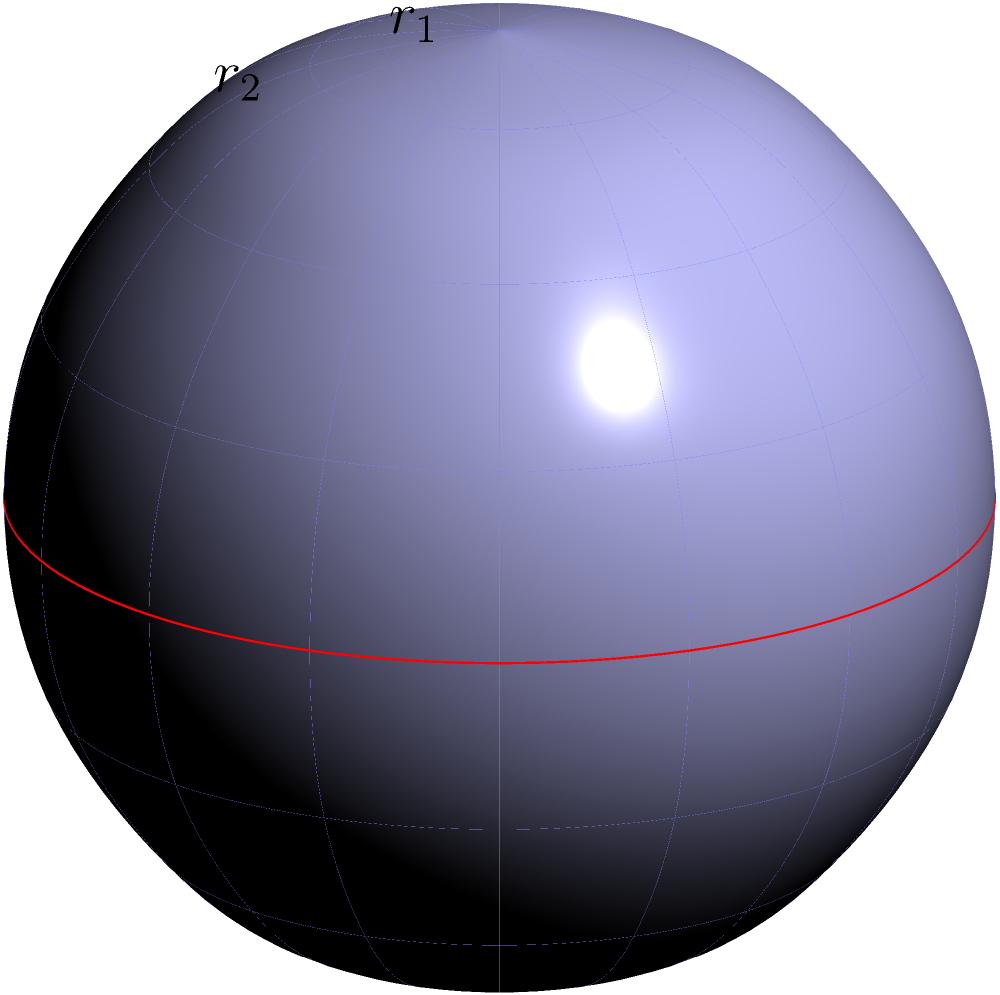On a sphere of radius $R$, two concentric circles are drawn with radii $r_1$ and $r_2$ (where $r_2 > r_1$) as measured along the surface of the sphere. If the area between these circles is $A$, express $A$ in terms of $R$, $r_1$, and $r_2$. To solve this problem, we'll follow these steps:

1) First, recall the formula for the area of a spherical cap: $A_{cap} = 2\pi R h$, where $R$ is the radius of the sphere and $h$ is the height of the cap.

2) The height $h$ can be expressed in terms of the radius $R$ and the circle radius $r$: $h = R - R \cos(\frac{r}{R})$

3) Therefore, the area of a spherical cap with radius $r$ is:
   $A_{cap} = 2\pi R^2 (1 - \cos(\frac{r}{R}))$

4) The area between our two concentric circles is the difference between the areas of two spherical caps:
   $A = A_{cap2} - A_{cap1}$

5) Substituting the formula from step 3:
   $A = 2\pi R^2 (1 - \cos(\frac{r_2}{R})) - 2\pi R^2 (1 - \cos(\frac{r_1}{R}))$

6) Simplifying:
   $A = 2\pi R^2 (\cos(\frac{r_1}{R}) - \cos(\frac{r_2}{R}))$

This formula gives us the area between two concentric circles on a sphere in terms of $R$, $r_1$, and $r_2$.
Answer: $A = 2\pi R^2 (\cos(\frac{r_1}{R}) - \cos(\frac{r_2}{R}))$ 